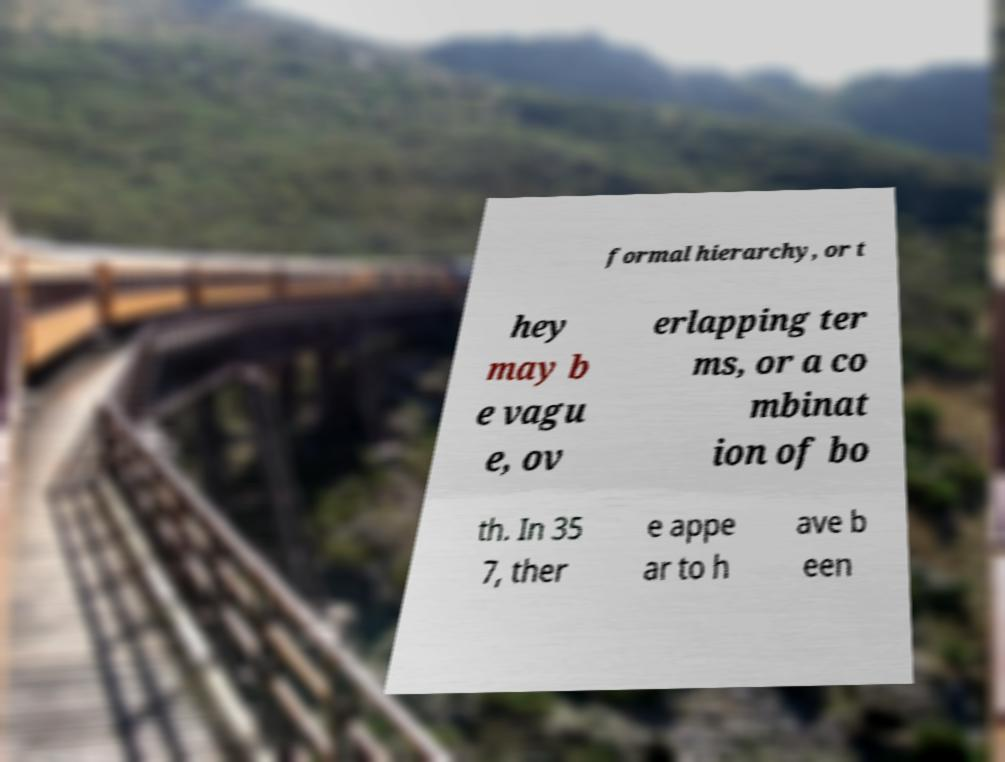Please identify and transcribe the text found in this image. formal hierarchy, or t hey may b e vagu e, ov erlapping ter ms, or a co mbinat ion of bo th. In 35 7, ther e appe ar to h ave b een 